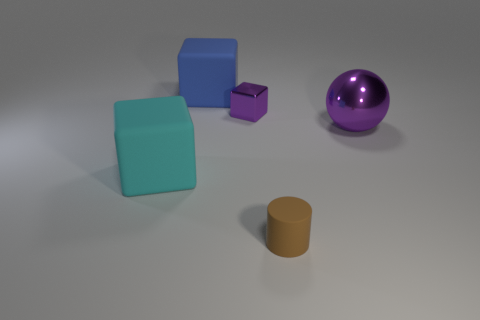Add 4 large gray shiny balls. How many objects exist? 9 Subtract all balls. How many objects are left? 4 Subtract 0 red spheres. How many objects are left? 5 Subtract all purple cubes. Subtract all blue blocks. How many objects are left? 3 Add 1 big blue rubber objects. How many big blue rubber objects are left? 2 Add 3 tiny cyan matte objects. How many tiny cyan matte objects exist? 3 